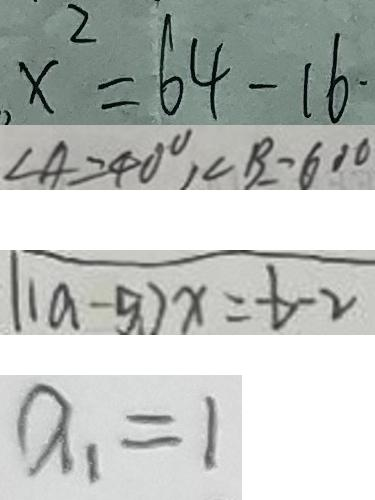Convert formula to latex. <formula><loc_0><loc_0><loc_500><loc_500>x ^ { 2 } = 6 4 - 1 6 . 
 \angle A = 4 0 ^ { \circ } , \angle B = 6 0 ^ { \circ } 
 ( 1 a - 5 ) x = - b - 2 
 a _ { 1 } = 1</formula> 